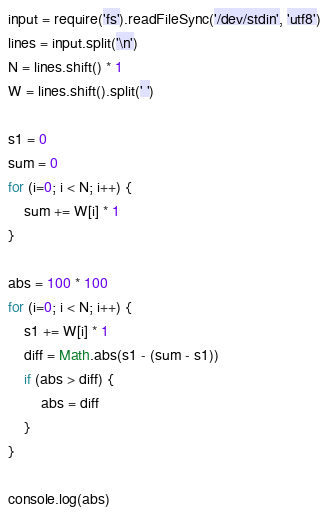Convert code to text. <code><loc_0><loc_0><loc_500><loc_500><_JavaScript_>input = require('fs').readFileSync('/dev/stdin', 'utf8')
lines = input.split('\n')
N = lines.shift() * 1
W = lines.shift().split(' ')

s1 = 0
sum = 0
for (i=0; i < N; i++) {
    sum += W[i] * 1
}

abs = 100 * 100
for (i=0; i < N; i++) {
    s1 += W[i] * 1
    diff = Math.abs(s1 - (sum - s1))
    if (abs > diff) {
        abs = diff
    } 
}

console.log(abs)
</code> 